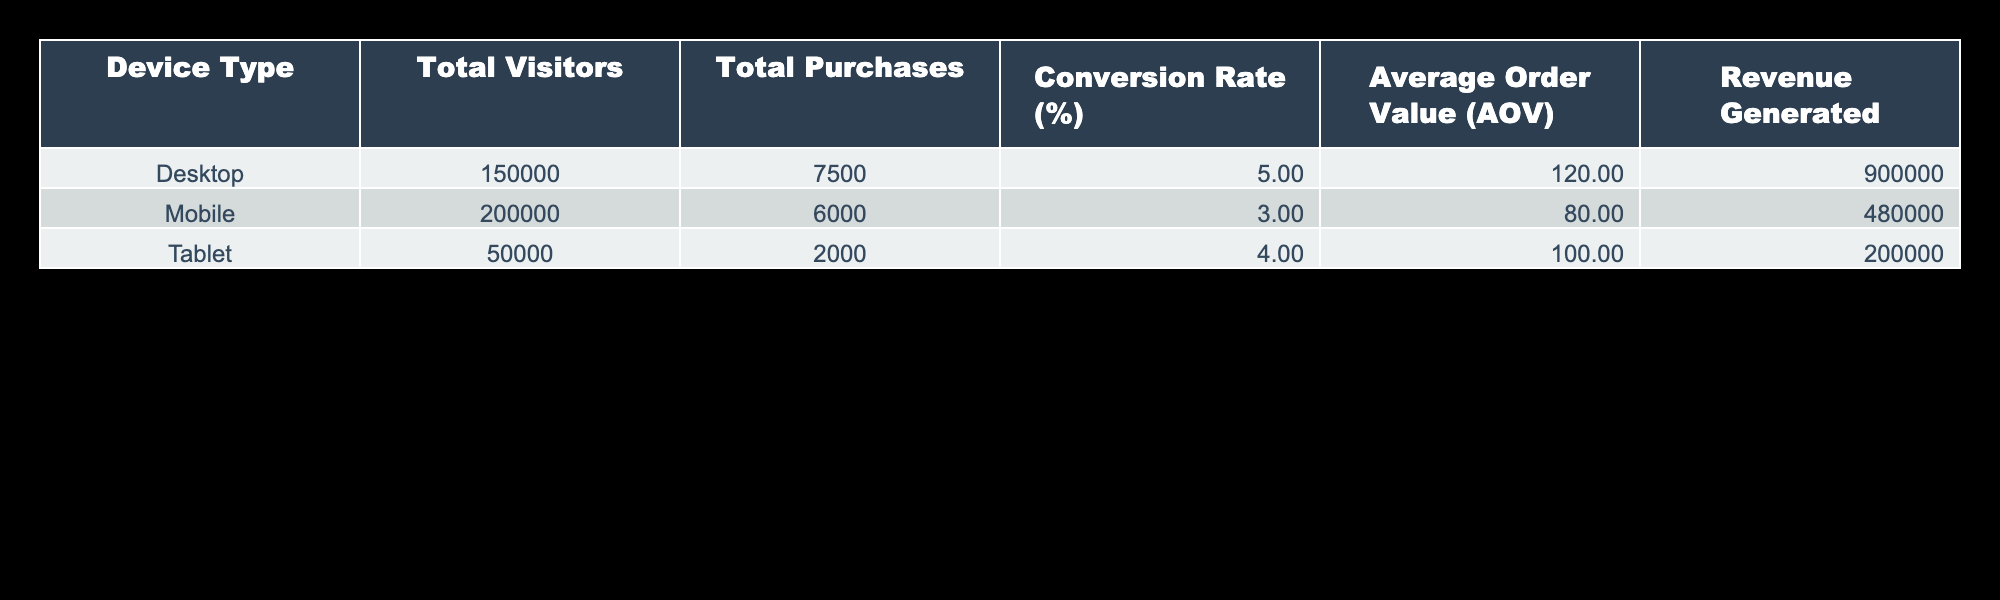What is the conversion rate for mobile devices? Referring to the table, the conversion rate for mobile devices is directly listed in the "Conversion Rate (%)" column for the "Mobile" row. It shows a value of 3.00%.
Answer: 3.00% How many total purchases were made on desktop devices? The "Total Purchases" column specifies that there were 7500 purchases made from desktop devices.
Answer: 7500 Which device type had the highest average order value? By comparing the "Average Order Value (AOV)" column for each device type, the desktop devices had an AOV of 120.00, which is higher than the other two (mobile and tablet).
Answer: Desktop What is the total revenue generated from tablet purchases? The "Revenue Generated" column for the tablet row shows that the total revenue from tablet purchases was 200,000.
Answer: 200000 Is it true that mobile devices had more total visitors than desktop devices? The total visitors for mobile devices (200,000) is greater than that for desktop devices (150,000) as shown in the "Total Visitors" column.
Answer: Yes What is the difference in total purchases between desktop and mobile devices? The total purchases for desktop (7500) can be compared to mobile (6000) to find the difference, calculated as 7500 - 6000 = 1500.
Answer: 1500 What is the average conversion rate across all device types? To find the average, sum the conversion rates (5.00 + 3.00 + 4.00 = 12.00) and divide by the number of device types (3). So, 12.00 / 3 = 4.00%.
Answer: 4.00% Which device type contributed the least to revenue generated? By comparing the values in the "Revenue Generated" column, mobile devices generated 480,000, desktop generated 900,000, and tablet generated 200,000. The lowest is for tablet devices.
Answer: Tablet What percentage of total visitors on desktop converted into purchases? The conversion rate for desktop in the table is given as 5%. This reflects the percentage of visitors (150,000) that resulted in the 7500 purchases.
Answer: 5% 